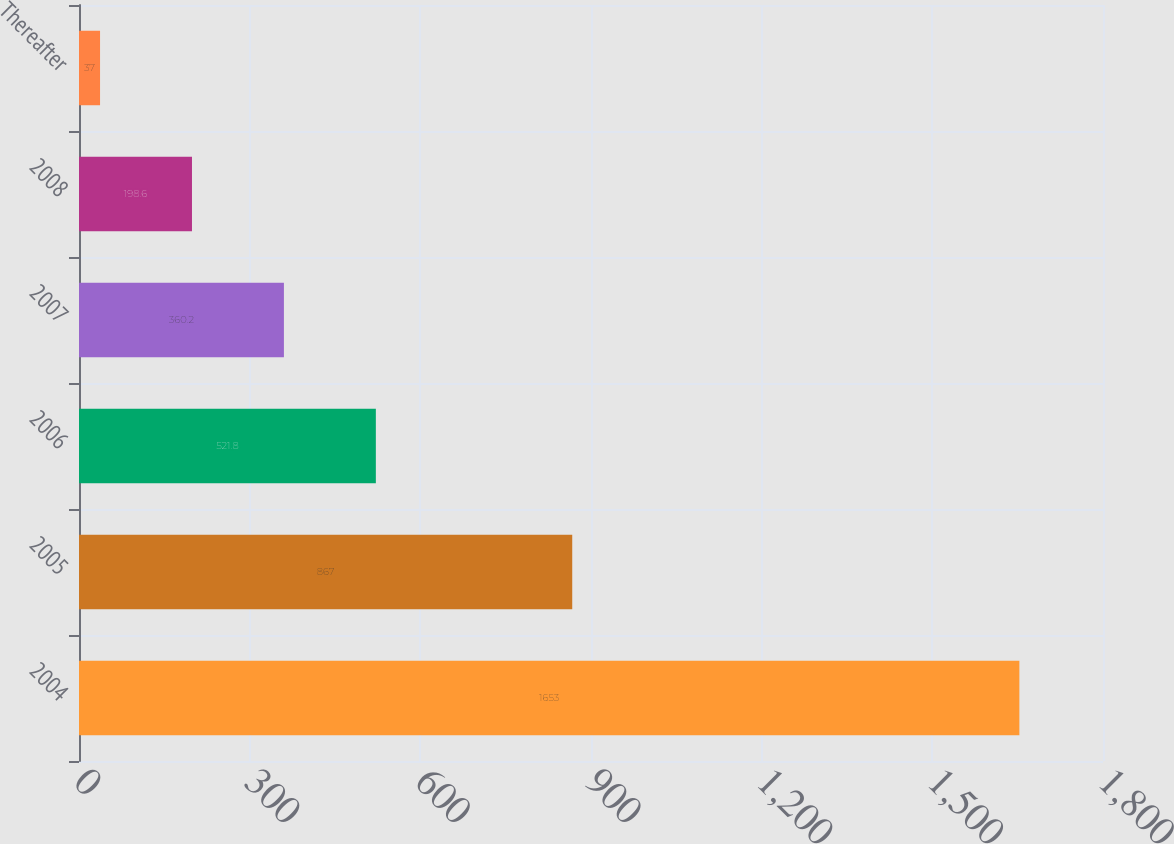<chart> <loc_0><loc_0><loc_500><loc_500><bar_chart><fcel>2004<fcel>2005<fcel>2006<fcel>2007<fcel>2008<fcel>Thereafter<nl><fcel>1653<fcel>867<fcel>521.8<fcel>360.2<fcel>198.6<fcel>37<nl></chart> 